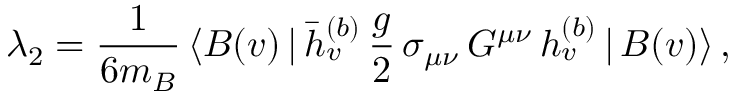Convert formula to latex. <formula><loc_0><loc_0><loc_500><loc_500>\lambda _ { 2 } = { \frac { 1 } { 6 m _ { B } } } \, \langle B ( v ) \, | \, \bar { h } _ { v } ^ { ( b ) } \, { \frac { g } { 2 } } \, \sigma _ { \mu \nu } \, G ^ { \mu \nu } \, h _ { v } ^ { ( b ) } \, | \, B ( v ) \rangle \, ,</formula> 